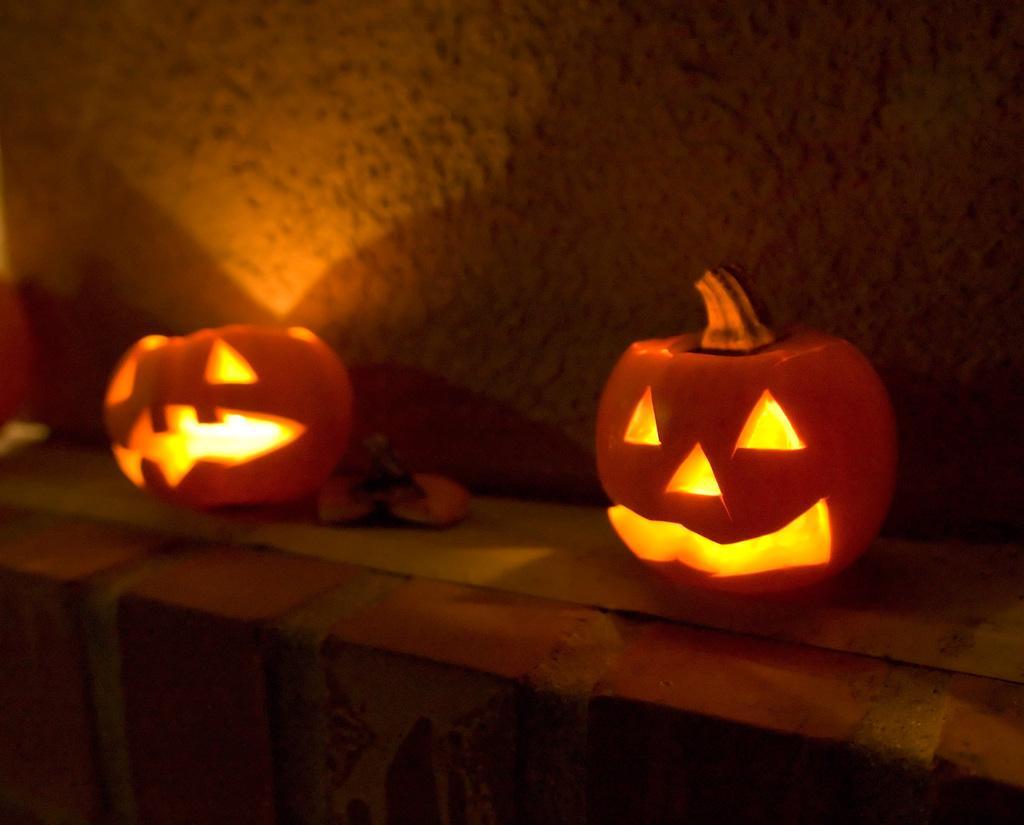Please provide a concise description of this image. In this image we can see pumpkins with lights on the wall. In the background of the image there is wall. 